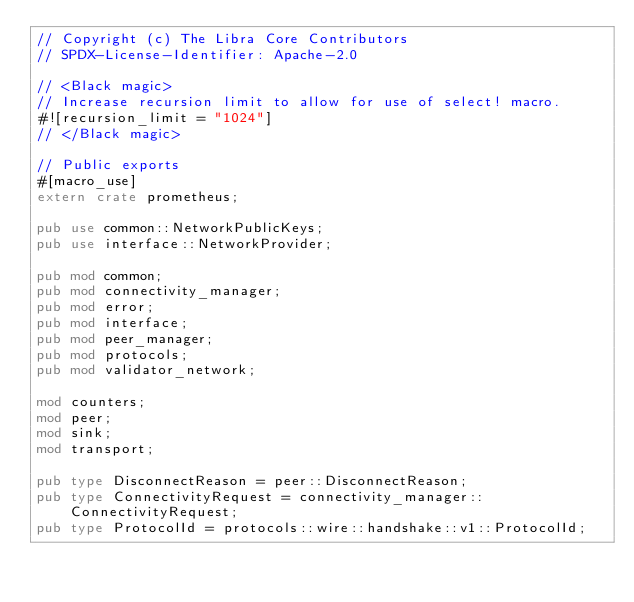<code> <loc_0><loc_0><loc_500><loc_500><_Rust_>// Copyright (c) The Libra Core Contributors
// SPDX-License-Identifier: Apache-2.0

// <Black magic>
// Increase recursion limit to allow for use of select! macro.
#![recursion_limit = "1024"]
// </Black magic>

// Public exports
#[macro_use]
extern crate prometheus;

pub use common::NetworkPublicKeys;
pub use interface::NetworkProvider;

pub mod common;
pub mod connectivity_manager;
pub mod error;
pub mod interface;
pub mod peer_manager;
pub mod protocols;
pub mod validator_network;

mod counters;
mod peer;
mod sink;
mod transport;

pub type DisconnectReason = peer::DisconnectReason;
pub type ConnectivityRequest = connectivity_manager::ConnectivityRequest;
pub type ProtocolId = protocols::wire::handshake::v1::ProtocolId;
</code> 